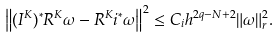Convert formula to latex. <formula><loc_0><loc_0><loc_500><loc_500>\left \| ( I ^ { K } ) ^ { * } R ^ { K } \omega - R ^ { K } i ^ { * } \omega \right \| ^ { 2 } \leq C _ { i } h ^ { 2 q - N + 2 } \| \omega \| _ { r } ^ { 2 } .</formula> 